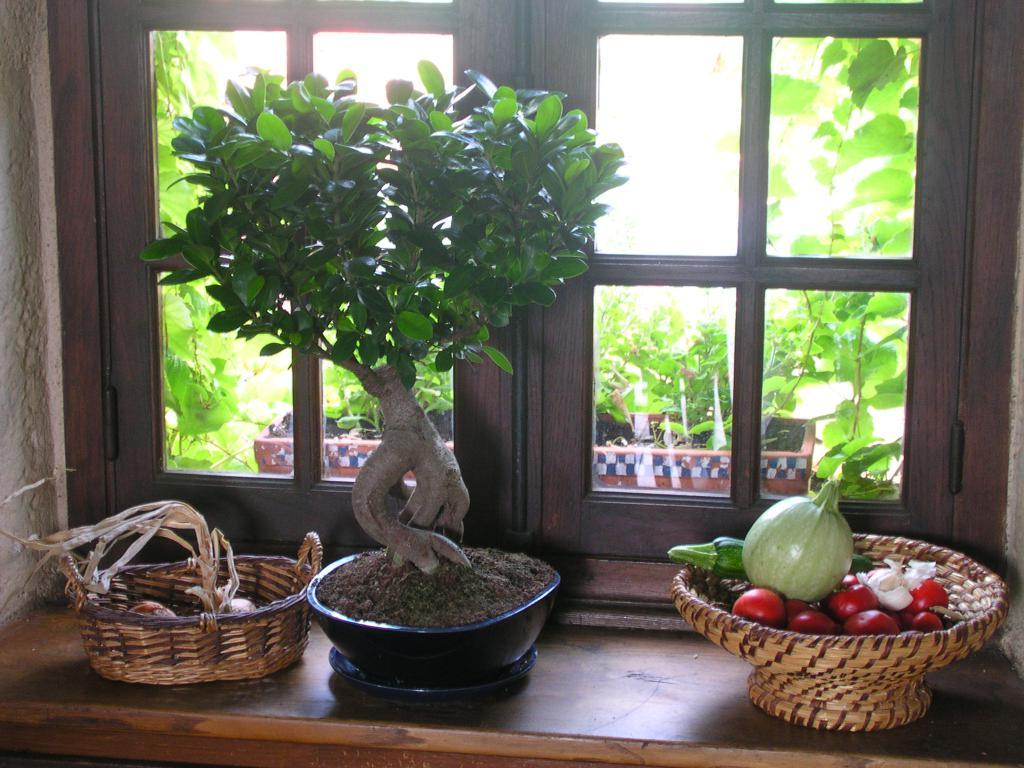What type of plants are in the image? There are plants in pots in the image. What else can be seen in the image besides the plants? There are vegetables and a wooden wicker basket visible in the image. What is the wooden furniture item in the image? There is a wooden desk in the image. Is there any source of natural light in the image? Yes, there is a window in the image. What type of bike is leaning against the wooden desk in the image? There is no bike present in the image; it only features plants in pots, vegetables, a wooden wicker basket, a wooden desk, and a window. 